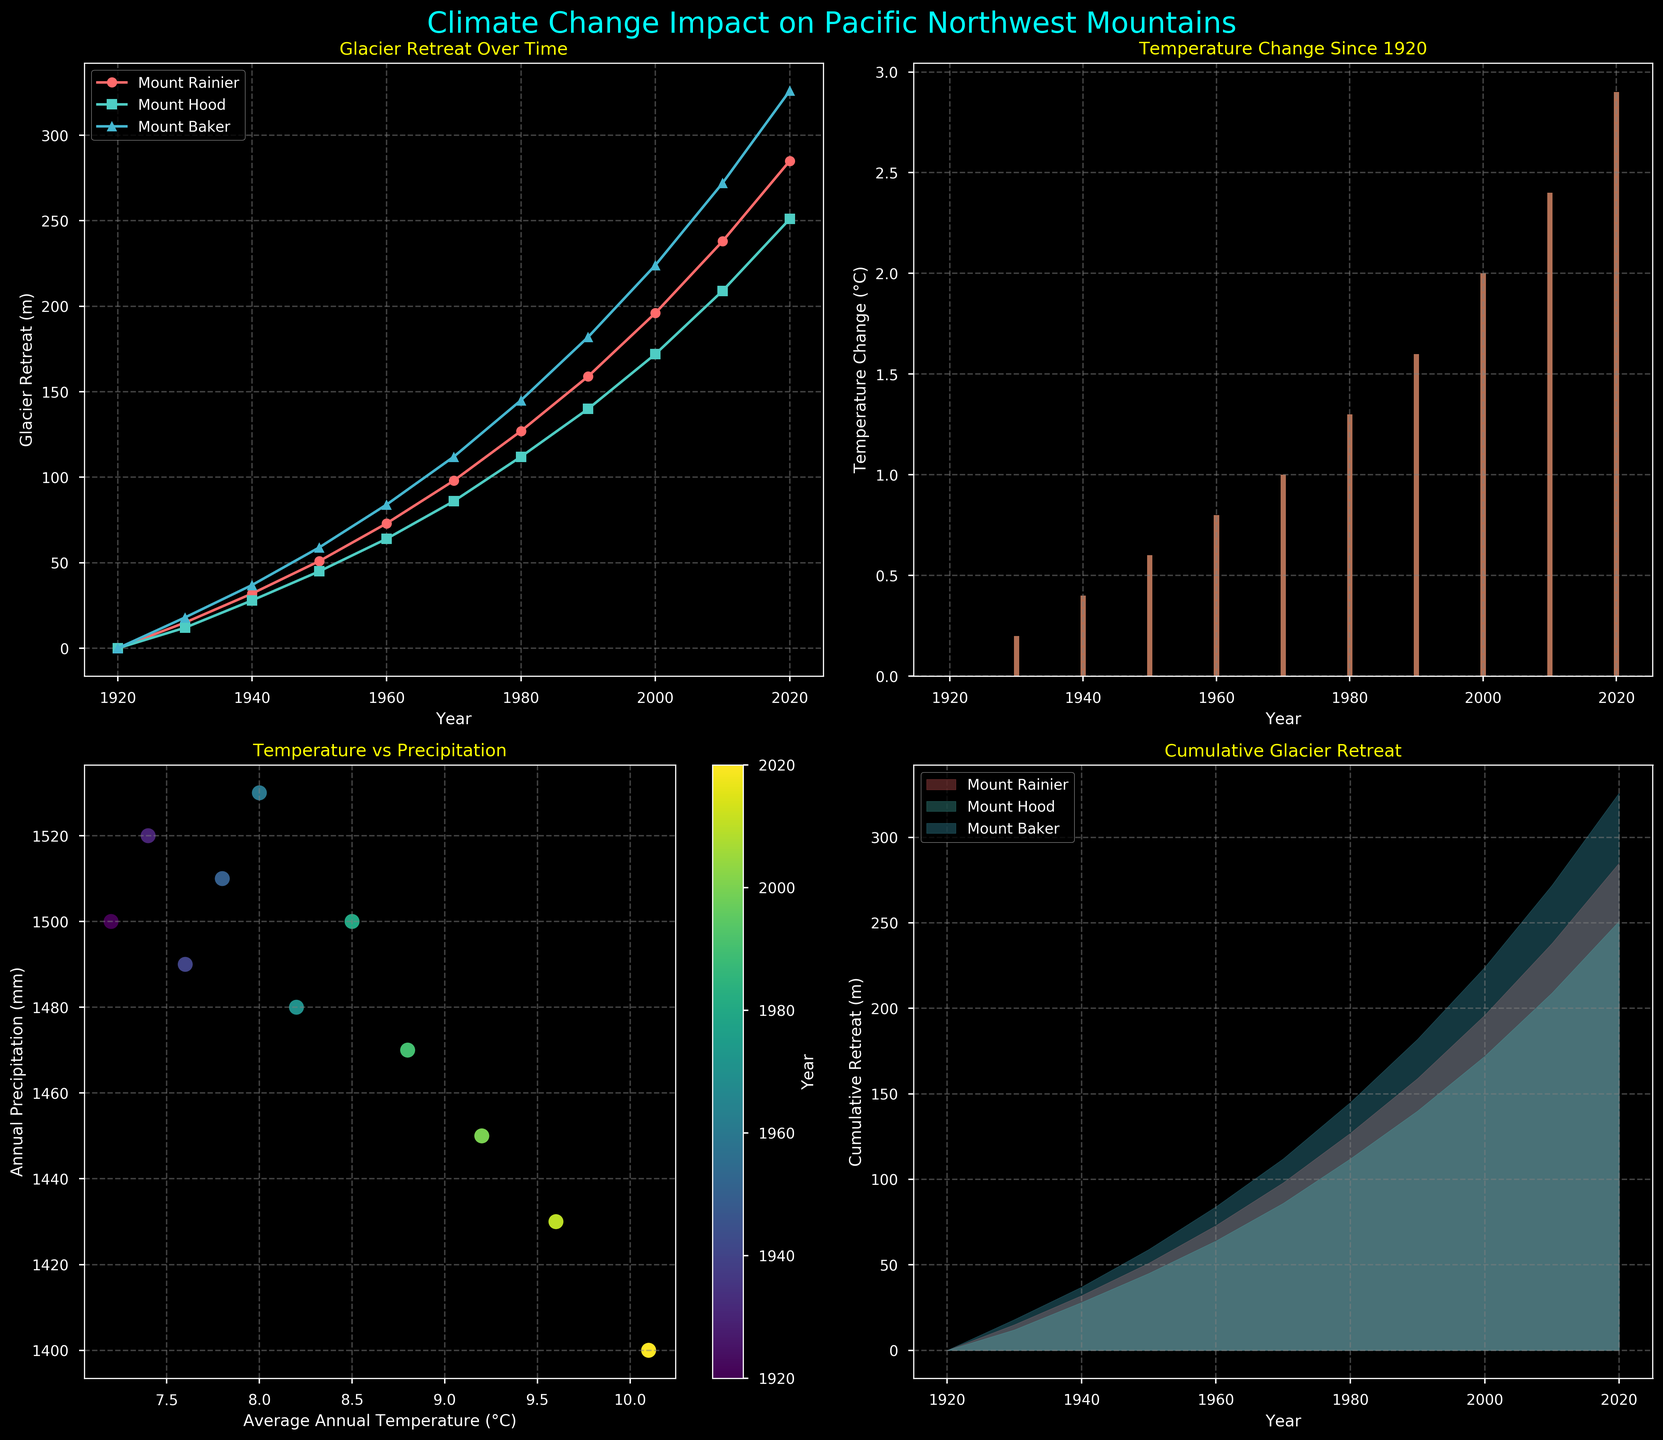What trend do we see in the glacier retreat for Mount Rainier from 1920 to 2020? The line plot in the top-left subplot shows a continuous increase in the retreat of Mount Rainier’s glacier over time, indicating a consistent glacial retreat.
Answer: Increasing trend By how much did the average annual temperature increase from 1920 to 2020? From the bar plot in the top-right subplot, the final height for 2020 shows an increase of 2.9°C compared to 1920. 10.1 (2020) - 7.2 (1920) = 2.9°C.
Answer: 2.9°C Which mountain has experienced the most glacier retreat by 2020? The line plot in the top-left subplot shows that Mount Baker has the highest glacier retreat value of 326 meters by 2020.
Answer: Mount Baker What was the temperature change from 1960 to 2020? The temperature change bar plot (top-right subplot) shows 2.1°C for 1960 and 2.9°C for 2020. Subtracting these gives 0.8°C.
Answer: 0.8°C What relationship is observed between average annual temperature and annual precipitation? The scatter plot in the bottom-left subplot displays a generally inverse relationship, with increasing temperatures associated with decreasing precipitation over the years.
Answer: Inverse relationship By how many meters did Mount Hood’s glacier retreat between 1990 and 2020? Referencing the line plot (top-left subplot), Mount Hood's glacier retreated from 140 meters in 1990 to 251 meters in 2020. The difference is 251 - 140 = 111 meters.
Answer: 111 meters How does the precipitation in 2020 compare to 1920? The scatter plot (bottom-left subplot) shows the annual precipitation at 1400mm in 2020 and 1500mm in 1920, indicating a decrease of 100mm.
Answer: Decreased by 100mm What is the cumulative glacier retreat for Mount Rainier, Mount Hood, and Mount Baker in 1970? From the line plot and stacked area plot, the cumulative retreat in 1970 can be calculated by summing 98 (Rainier) + 86 (Hood) + 112 (Baker) = 296 meters.
Answer: 296 meters Which year had the highest annual precipitation according to the scatter plot? The color bar in the bottom-left subplot indicates that the year 1960 had the highest precipitation at 1530 mm.
Answer: 1960 